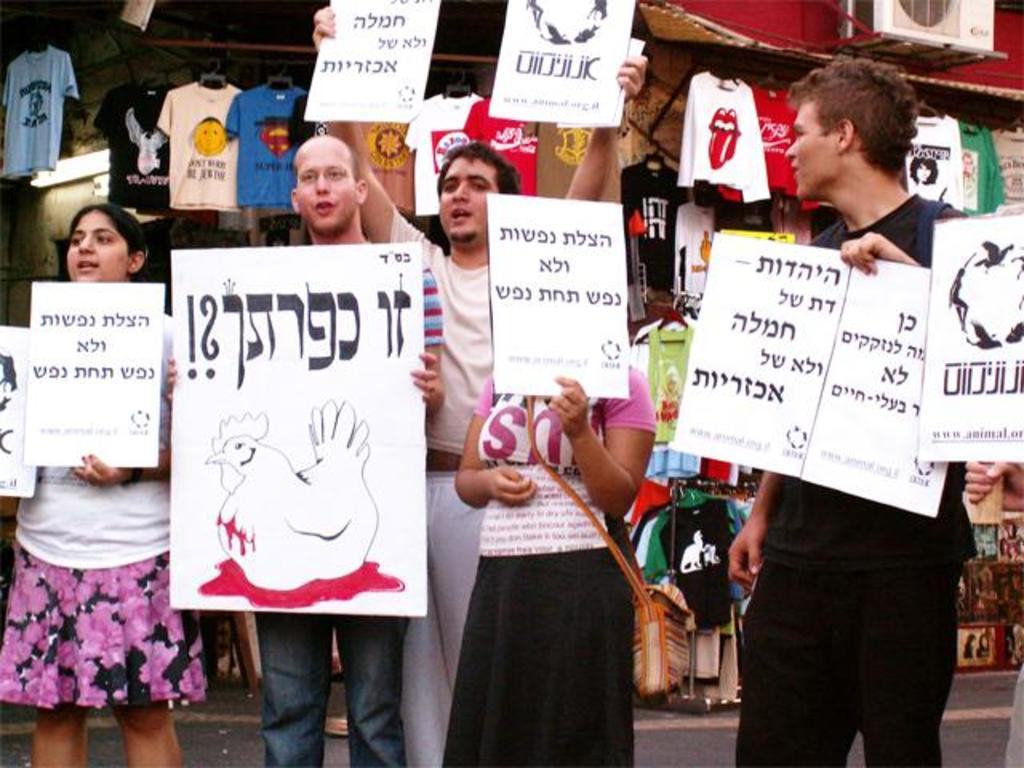What are the people in the image doing? The people in the image are holding cards. Where are the people standing in the image? The people are standing on a road. What can be seen in the background of the image? Clothes, an air conditioner outdoor unit, and other objects are visible in the background. What type of hat is the person wearing in the image? There is no person wearing a hat in the image. What fruit can be seen in the hands of the people holding cards? There is no fruit present in the image; the people are holding cards. 